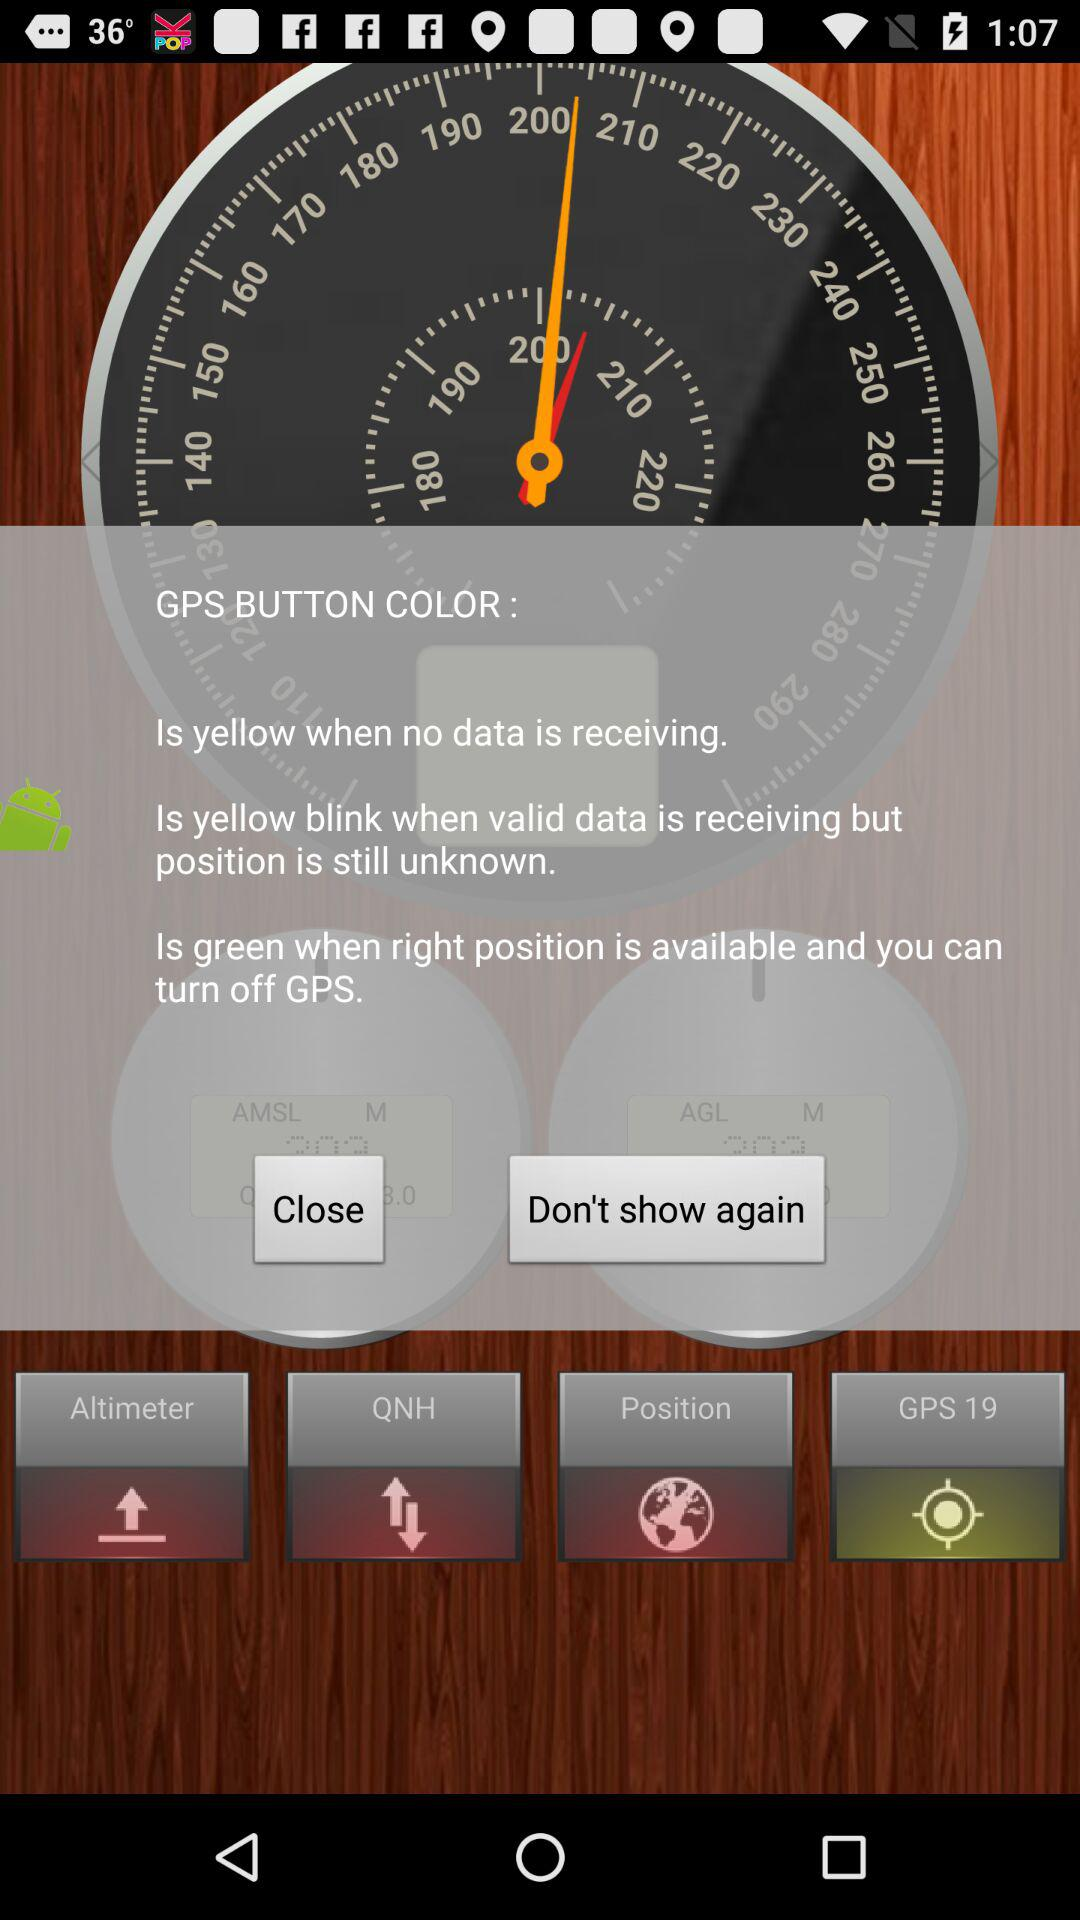What does it mean when the yellow light blinks? The yellow light blinks when valid data is receiving but position is still unknown. 